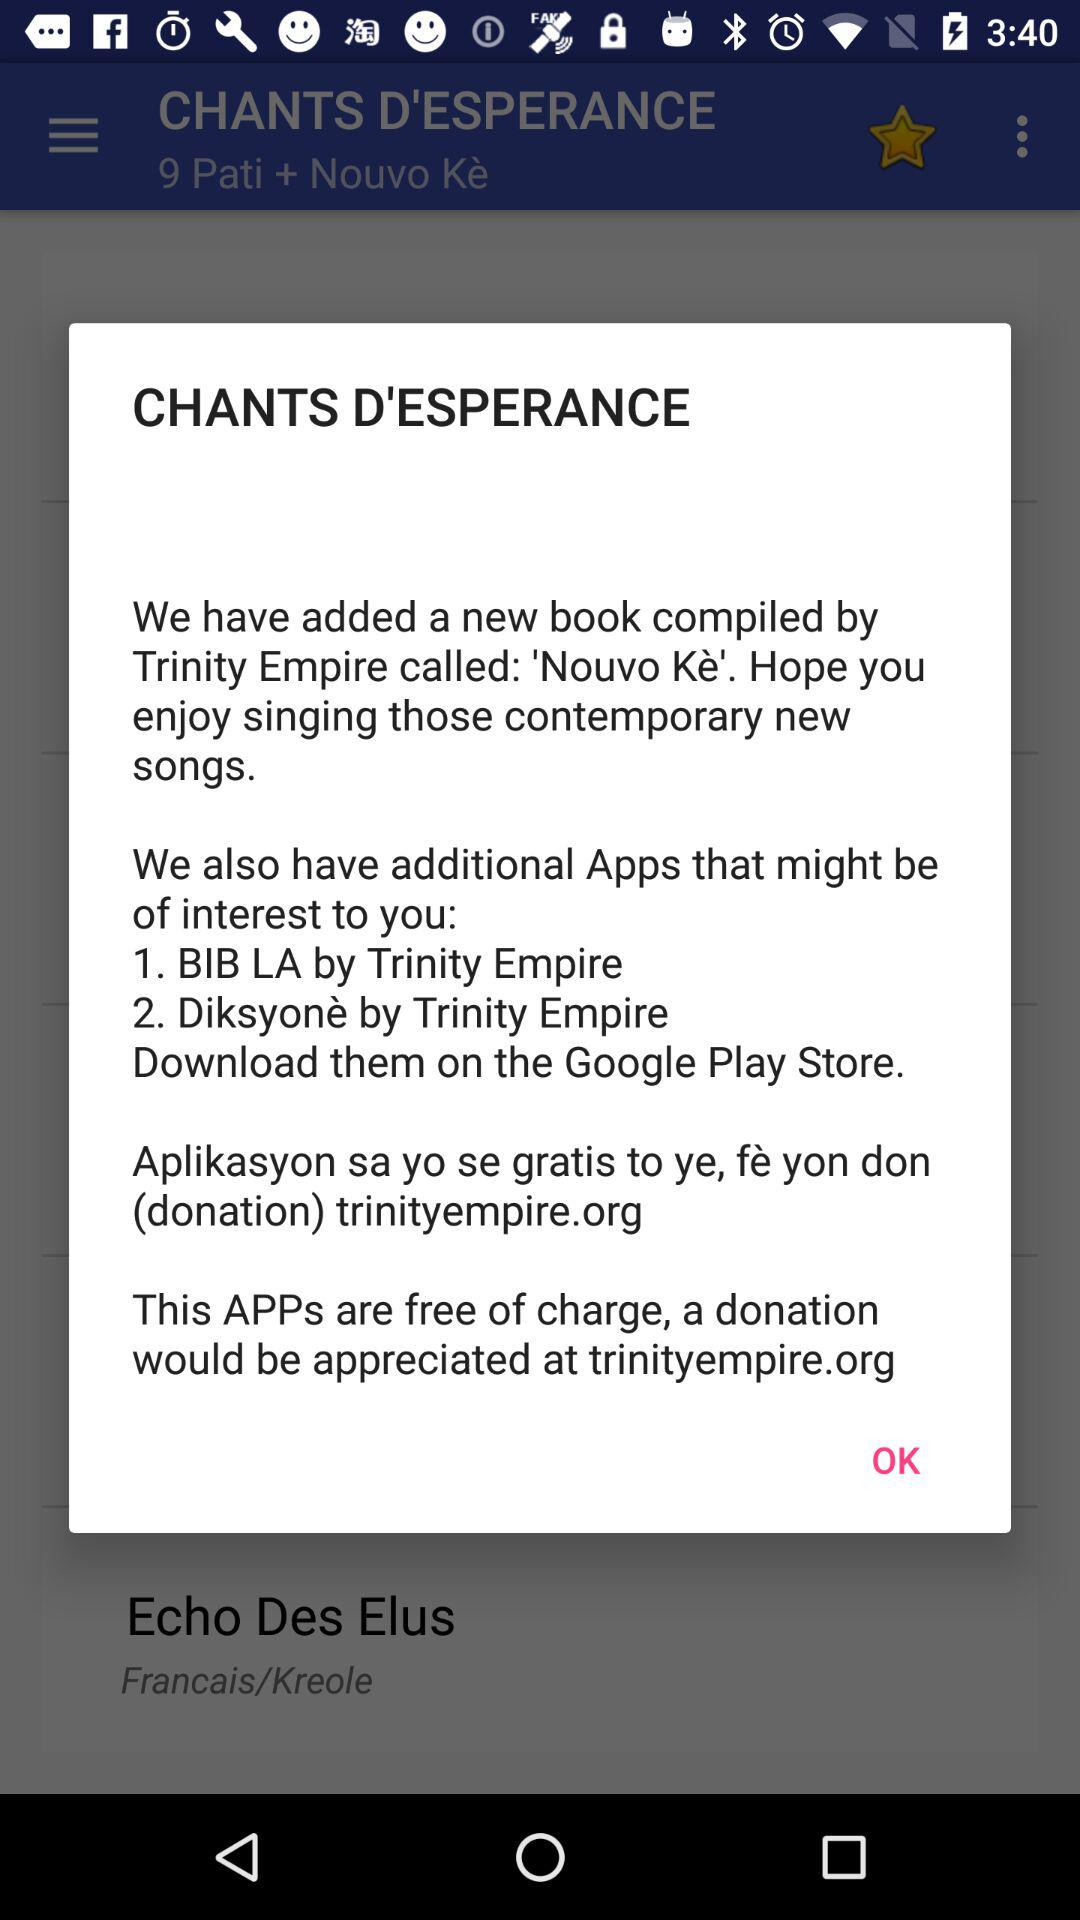What is the name of the book? The name of the book is "Nouvo Ke". 